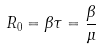Convert formula to latex. <formula><loc_0><loc_0><loc_500><loc_500>R _ { 0 } = \beta \tau = { \frac { \beta } { \mu } }</formula> 